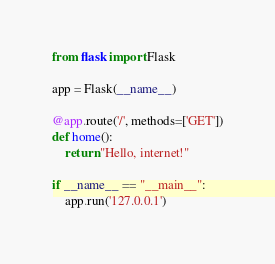Convert code to text. <code><loc_0><loc_0><loc_500><loc_500><_Python_>from flask import Flask

app = Flask(__name__)

@app.route('/', methods=['GET'])
def home():
    return "Hello, internet!"

if __name__ == "__main__":
    app.run('127.0.0.1')</code> 